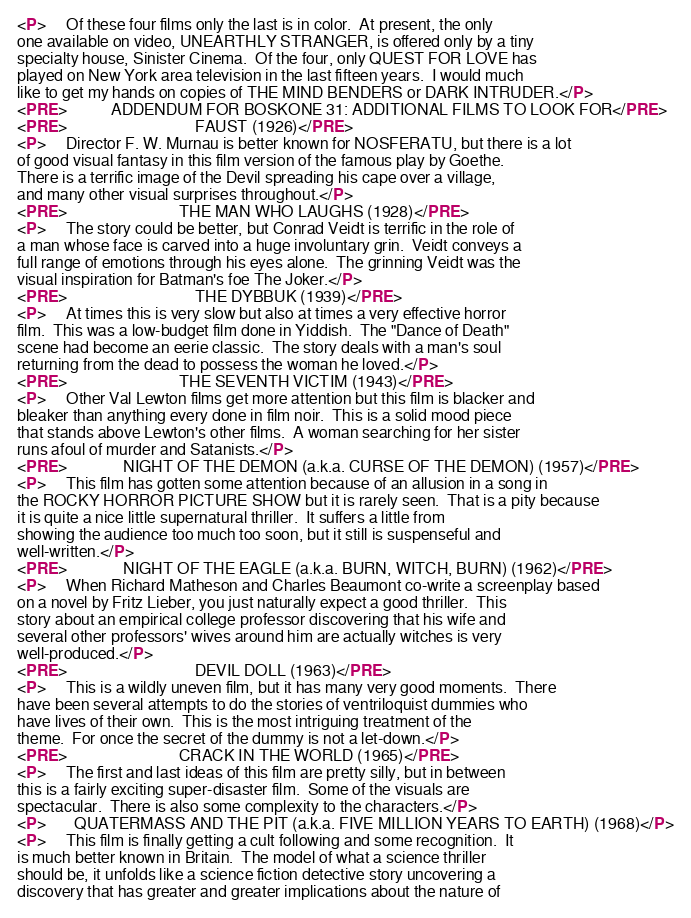<code> <loc_0><loc_0><loc_500><loc_500><_HTML_><P>     Of these four films only the last is in color.  At present, the only
one available on video, UNEARTHLY STRANGER, is offered only by a tiny
specialty house, Sinister Cinema.  Of the four, only QUEST FOR LOVE has
played on New York area television in the last fifteen years.  I would much
like to get my hands on copies of THE MIND BENDERS or DARK INTRUDER.</P>
<PRE>           ADDENDUM FOR BOSKONE 31: ADDITIONAL FILMS TO LOOK FOR</PRE>
<PRE>                                FAUST (1926)</PRE>
<P>     Director F. W. Murnau is better known for NOSFERATU, but there is a lot
of good visual fantasy in this film version of the famous play by Goethe.
There is a terrific image of the Devil spreading his cape over a village,
and many other visual surprises throughout.</P>
<PRE>                            THE MAN WHO LAUGHS (1928)</PRE>
<P>     The story could be better, but Conrad Veidt is terrific in the role of
a man whose face is carved into a huge involuntary grin.  Veidt conveys a
full range of emotions through his eyes alone.  The grinning Veidt was the
visual inspiration for Batman's foe The Joker.</P>
<PRE>                                THE DYBBUK (1939)</PRE>
<P>     At times this is very slow but also at times a very effective horror
film.  This was a low-budget film done in Yiddish.  The "Dance of Death"
scene had become an eerie classic.  The story deals with a man's soul
returning from the dead to possess the woman he loved.</P>
<PRE>                            THE SEVENTH VICTIM (1943)</PRE>
<P>     Other Val Lewton films get more attention but this film is blacker and
bleaker than anything every done in film noir.  This is a solid mood piece
that stands above Lewton's other films.  A woman searching for her sister
runs afoul of murder and Satanists.</P>
<PRE>              NIGHT OF THE DEMON (a.k.a. CURSE OF THE DEMON) (1957)</PRE>
<P>     This film has gotten some attention because of an allusion in a song in
the ROCKY HORROR PICTURE SHOW but it is rarely seen.  That is a pity because
it is quite a nice little supernatural thriller.  It suffers a little from
showing the audience too much too soon, but it still is suspenseful and
well-written.</P>
<PRE>              NIGHT OF THE EAGLE (a.k.a. BURN, WITCH, BURN) (1962)</PRE>
<P>     When Richard Matheson and Charles Beaumont co-write a screenplay based
on a novel by Fritz Lieber, you just naturally expect a good thriller.  This
story about an empirical college professor discovering that his wife and
several other professors' wives around him are actually witches is very
well-produced.</P>
<PRE>                                DEVIL DOLL (1963)</PRE>
<P>     This is a wildly uneven film, but it has many very good moments.  There
have been several attempts to do the stories of ventriloquist dummies who
have lives of their own.  This is the most intriguing treatment of the
theme.  For once the secret of the dummy is not a let-down.</P>
<PRE>                            CRACK IN THE WORLD (1965)</PRE>
<P>     The first and last ideas of this film are pretty silly, but in between
this is a fairly exciting super-disaster film.  Some of the visuals are
spectacular.  There is also some complexity to the characters.</P>
<P>       QUATERMASS AND THE PIT (a.k.a. FIVE MILLION YEARS TO EARTH) (1968)</P>
<P>     This film is finally getting a cult following and some recognition.  It
is much better known in Britain.  The model of what a science thriller
should be, it unfolds like a science fiction detective story uncovering a
discovery that has greater and greater implications about the nature of</code> 